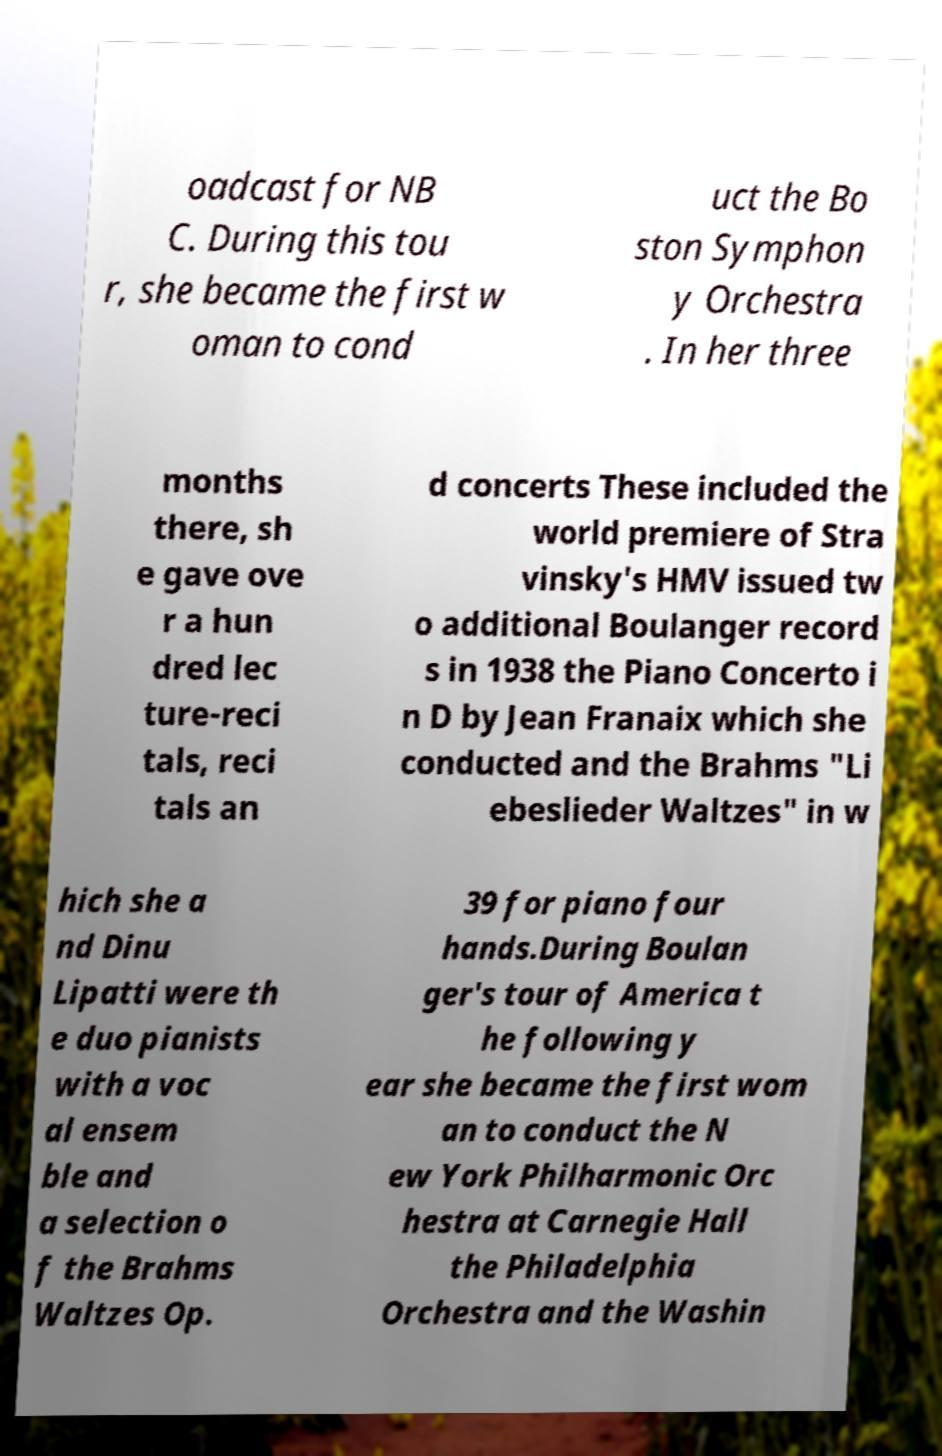Can you accurately transcribe the text from the provided image for me? oadcast for NB C. During this tou r, she became the first w oman to cond uct the Bo ston Symphon y Orchestra . In her three months there, sh e gave ove r a hun dred lec ture-reci tals, reci tals an d concerts These included the world premiere of Stra vinsky's HMV issued tw o additional Boulanger record s in 1938 the Piano Concerto i n D by Jean Franaix which she conducted and the Brahms "Li ebeslieder Waltzes" in w hich she a nd Dinu Lipatti were th e duo pianists with a voc al ensem ble and a selection o f the Brahms Waltzes Op. 39 for piano four hands.During Boulan ger's tour of America t he following y ear she became the first wom an to conduct the N ew York Philharmonic Orc hestra at Carnegie Hall the Philadelphia Orchestra and the Washin 